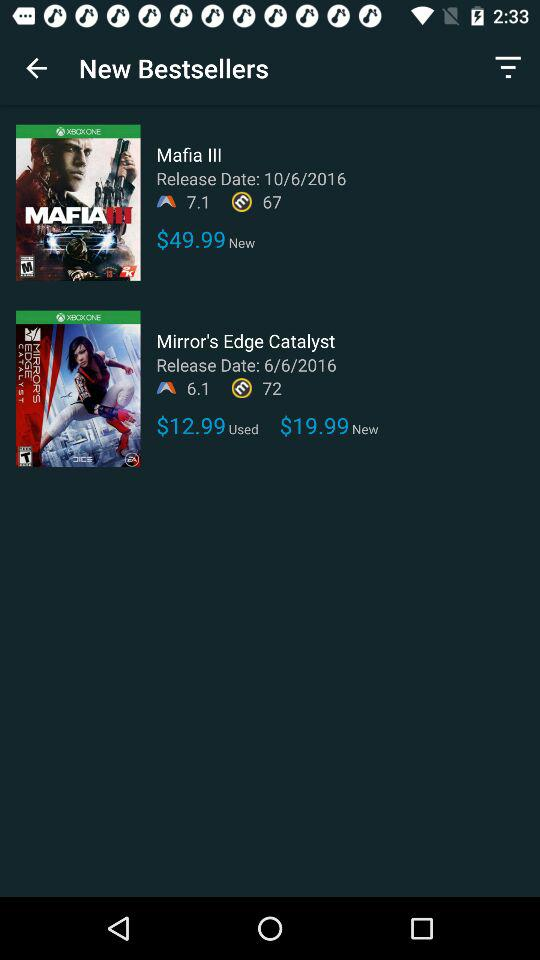How much more does the new version of Mirror's Edge Catalyst cost than the used version?
Answer the question using a single word or phrase. $7.00 